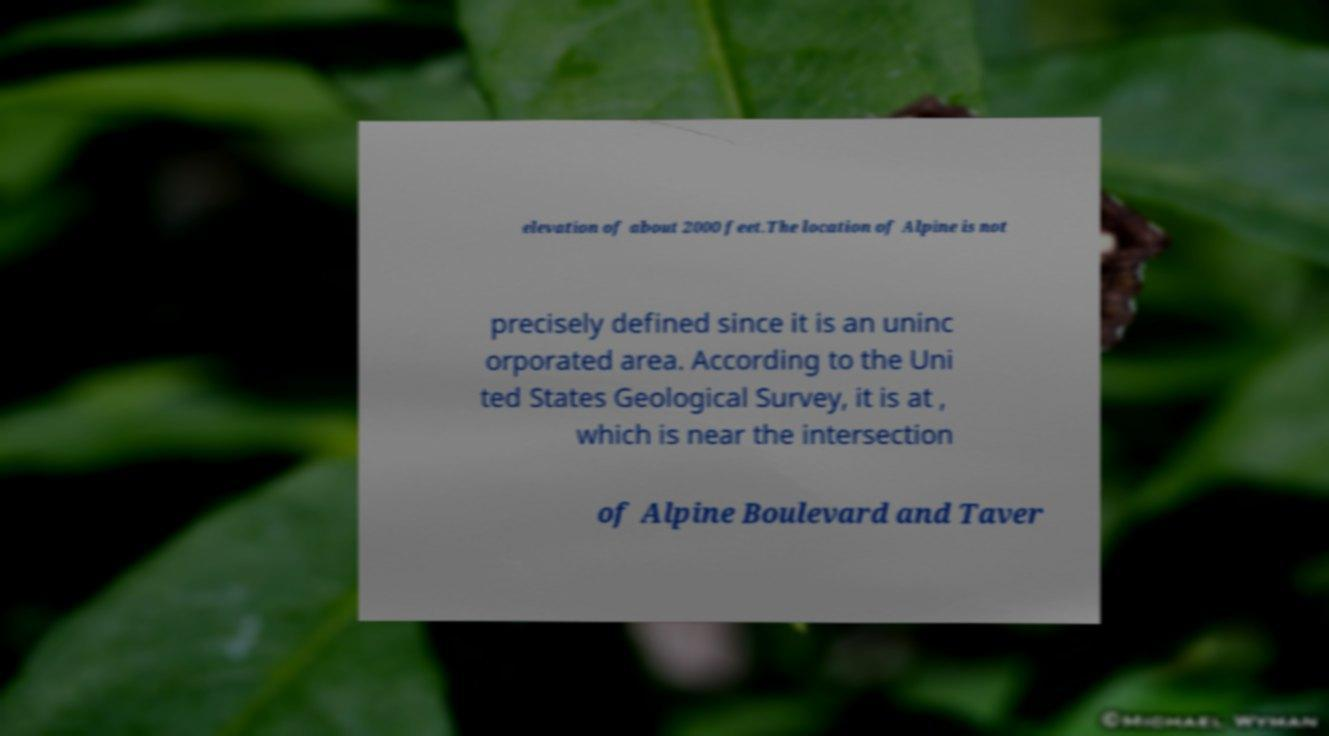I need the written content from this picture converted into text. Can you do that? elevation of about 2000 feet.The location of Alpine is not precisely defined since it is an uninc orporated area. According to the Uni ted States Geological Survey, it is at , which is near the intersection of Alpine Boulevard and Taver 